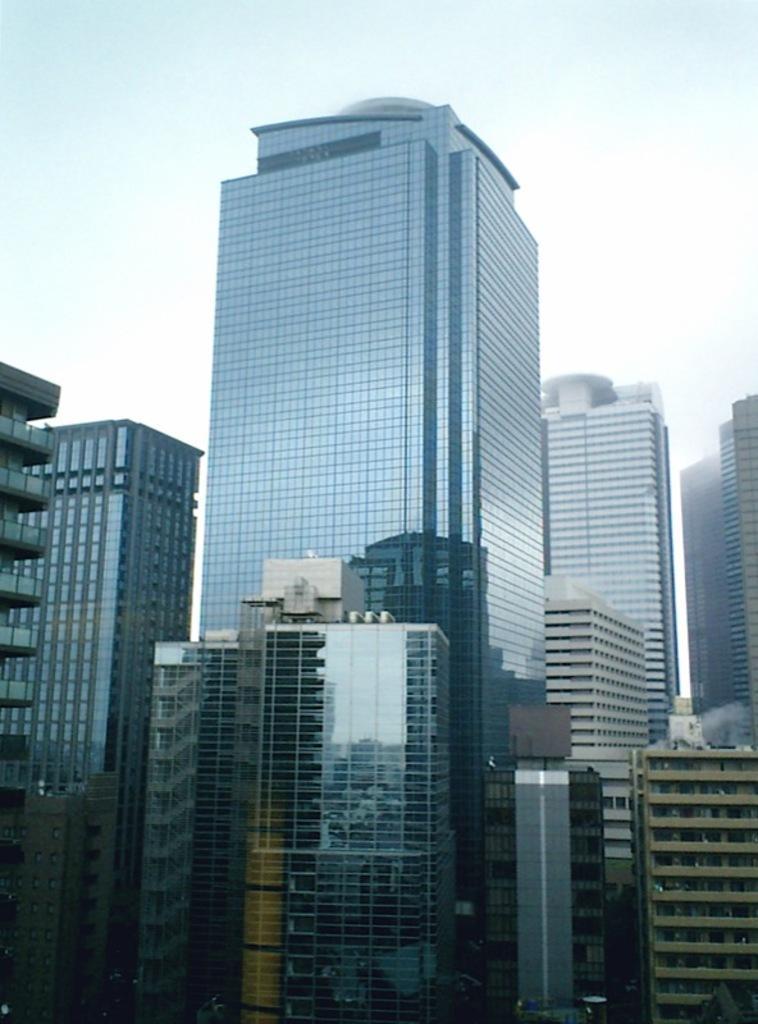In one or two sentences, can you explain what this image depicts? In this picture we can see some buildings here, we can also see glasses and windows of theses buildings, there is sky at the top of the picture. 